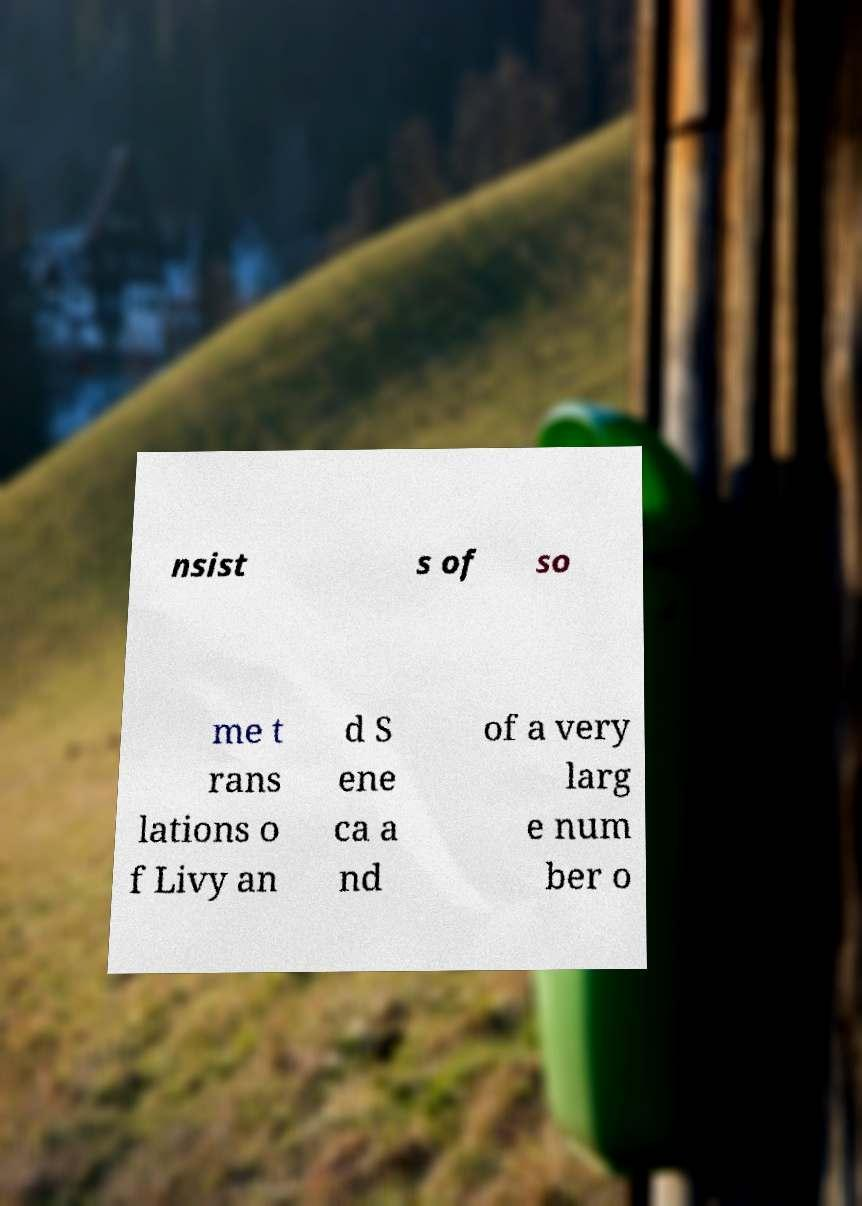For documentation purposes, I need the text within this image transcribed. Could you provide that? nsist s of so me t rans lations o f Livy an d S ene ca a nd of a very larg e num ber o 